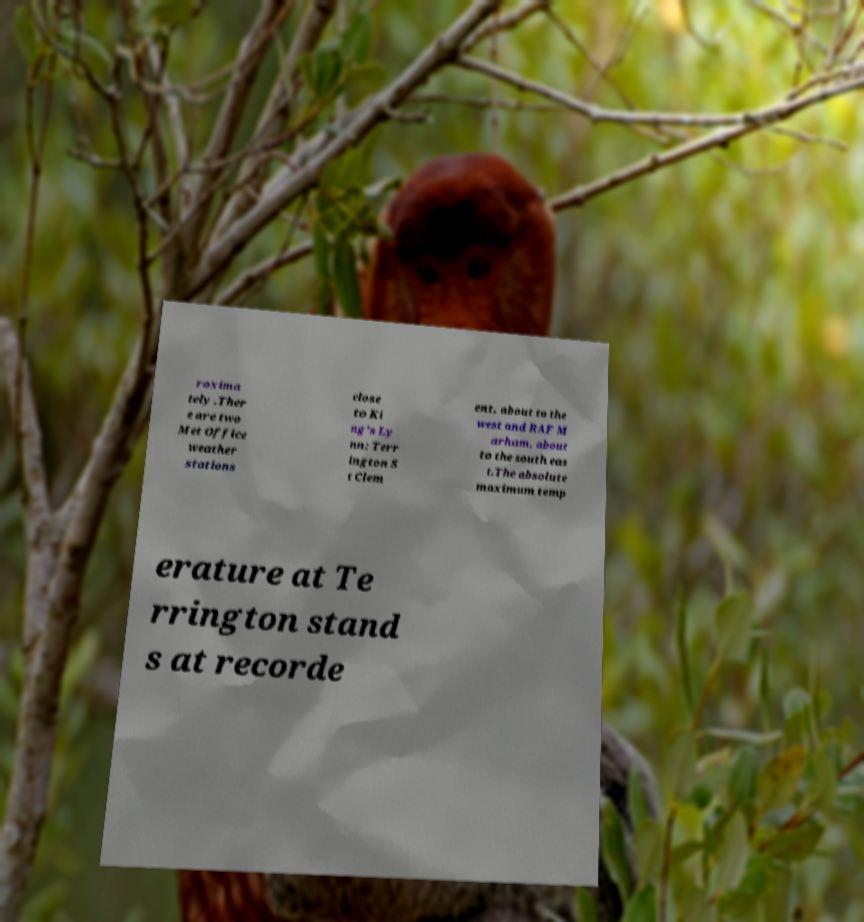Please read and relay the text visible in this image. What does it say? roxima tely .Ther e are two Met Office weather stations close to Ki ng's Ly nn: Terr ington S t Clem ent, about to the west and RAF M arham, about to the south eas t.The absolute maximum temp erature at Te rrington stand s at recorde 